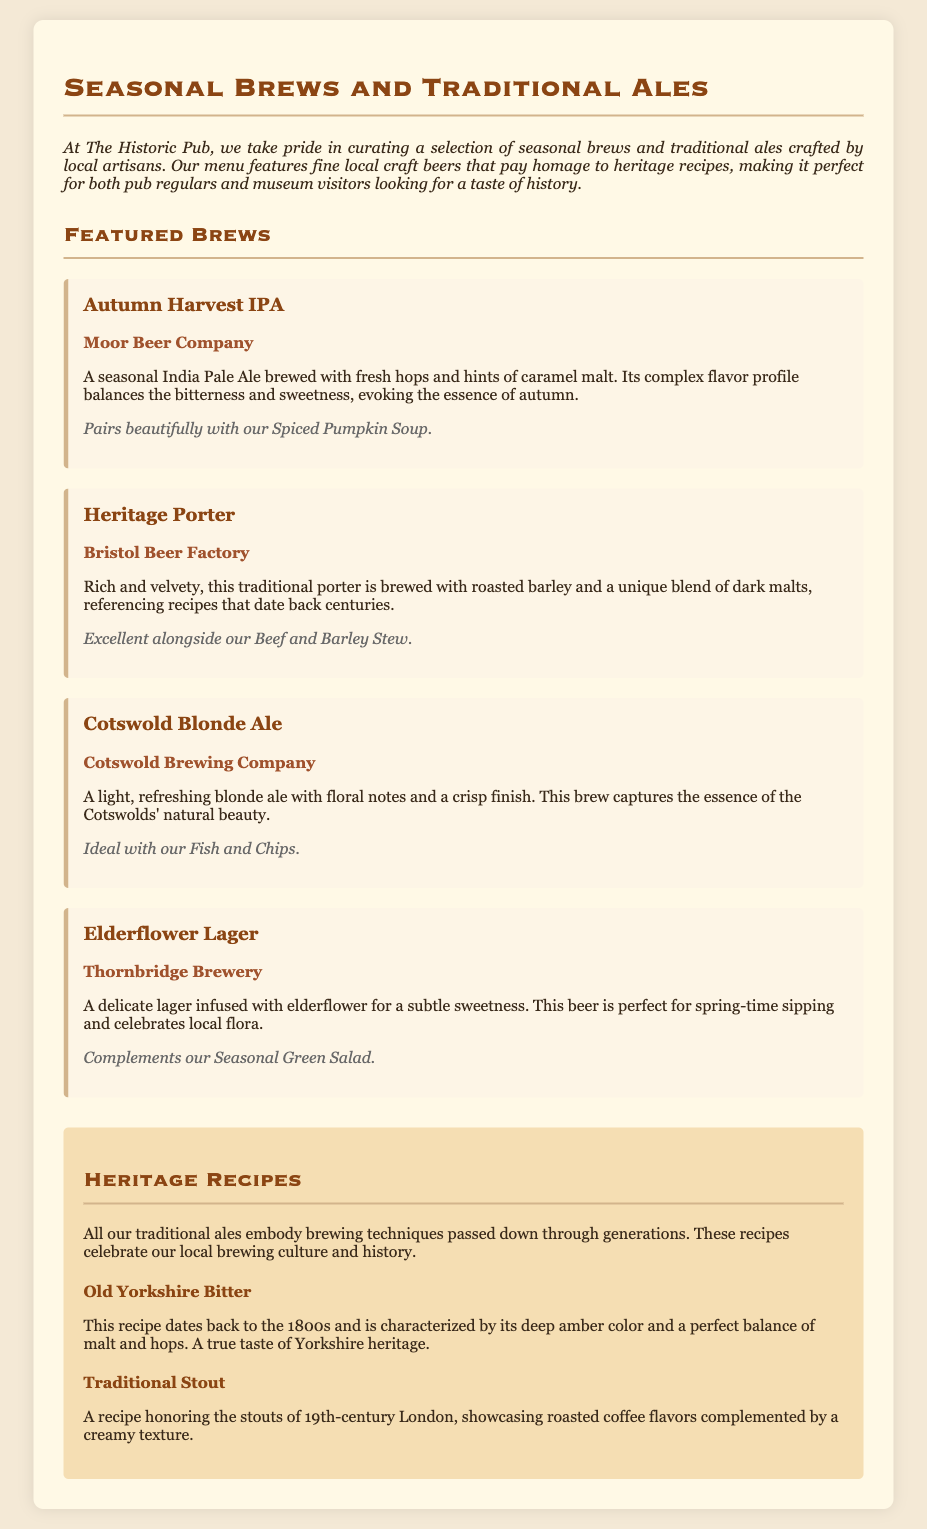What is the title of the menu? The title clearly stated at the top of the document is "Seasonal Brews and Traditional Ales."
Answer: Seasonal Brews and Traditional Ales Who brews the Autumn Harvest IPA? The brewery responsible for this specific seasonal brew is mentioned as "Moor Beer Company."
Answer: Moor Beer Company What flavor notes are included in the Heritage Porter? The flavor profile noted for the Heritage Porter includes "roasted barley" and "dark malts."
Answer: roasted barley and dark malts Which dish pairs well with the Cotswold Blonde Ale? The menu lists "Fish and Chips" as the dish that pairs ideally with this brew.
Answer: Fish and Chips What historical aspect does the Old Yorkshire Bitter recipe represent? The Old Yorkshire Bitter is characterized as being rooted in a recipe that dates back to "the 1800s."
Answer: the 1800s Which beer is described as having a subtle sweetness due to elderflower? The Elderflower Lager is explicitly stated to be infused with elderflower for its subtle sweetness.
Answer: Elderflower Lager What is the main characteristic of the Traditional Stout recipe? The Traditional Stout is noted for showcasing "roasted coffee flavors" complemented by a creamy texture.
Answer: roasted coffee flavors 